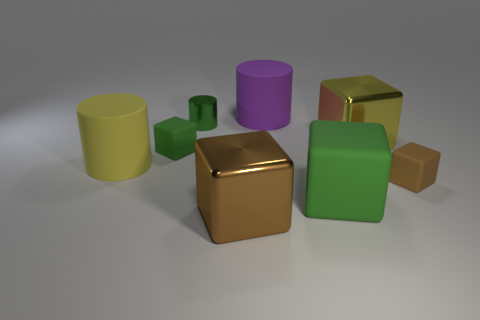Is there a big purple cylinder that has the same material as the purple thing? no 